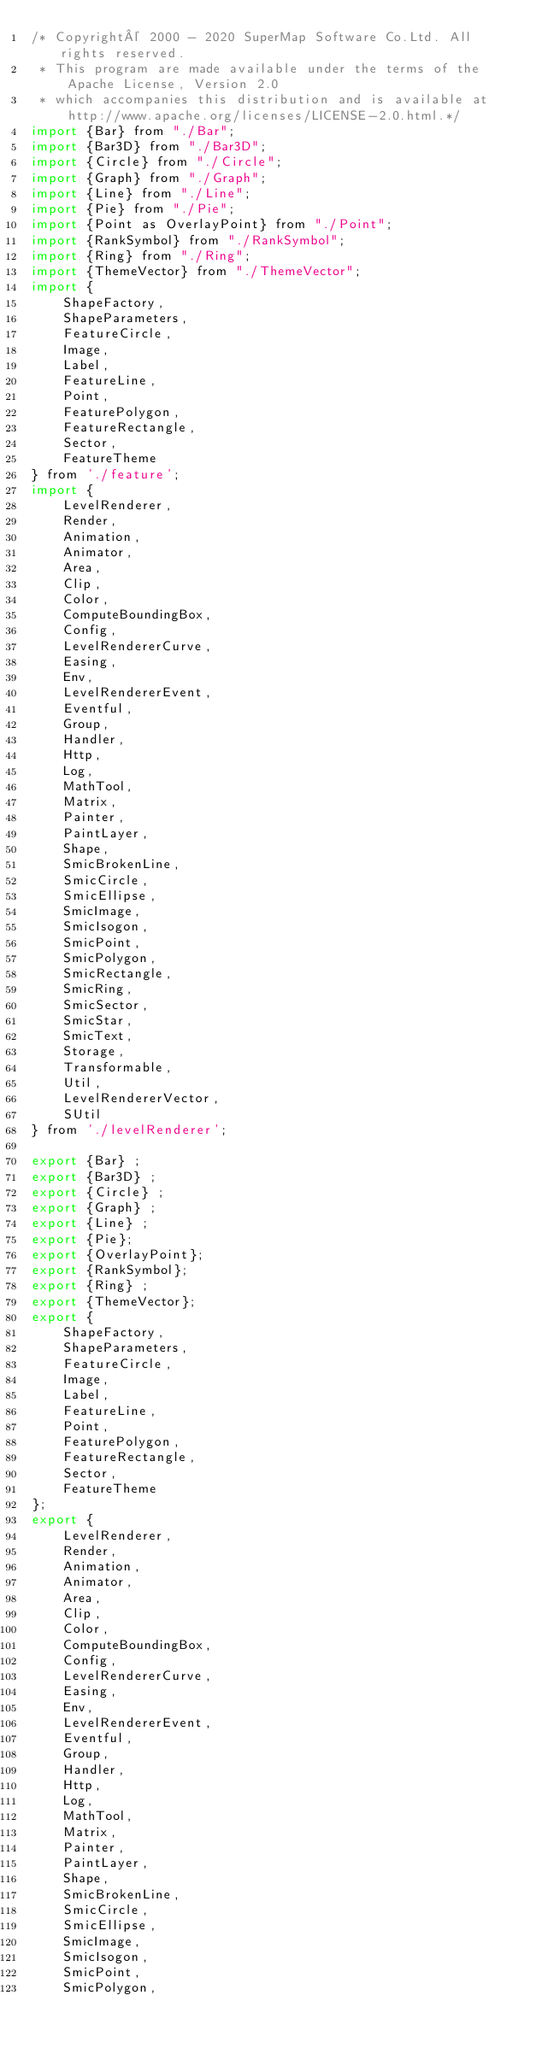Convert code to text. <code><loc_0><loc_0><loc_500><loc_500><_JavaScript_>/* Copyright© 2000 - 2020 SuperMap Software Co.Ltd. All rights reserved.
 * This program are made available under the terms of the Apache License, Version 2.0
 * which accompanies this distribution and is available at http://www.apache.org/licenses/LICENSE-2.0.html.*/
import {Bar} from "./Bar";
import {Bar3D} from "./Bar3D";
import {Circle} from "./Circle";
import {Graph} from "./Graph";
import {Line} from "./Line";
import {Pie} from "./Pie";
import {Point as OverlayPoint} from "./Point";
import {RankSymbol} from "./RankSymbol";
import {Ring} from "./Ring";
import {ThemeVector} from "./ThemeVector";
import {
    ShapeFactory,
    ShapeParameters,
    FeatureCircle,
    Image,
    Label,
    FeatureLine,
    Point,
    FeaturePolygon,
    FeatureRectangle,
    Sector,
    FeatureTheme
} from './feature';
import {
    LevelRenderer,
    Render,
    Animation,
    Animator,
    Area,
    Clip,
    Color,
    ComputeBoundingBox,
    Config,
    LevelRendererCurve,
    Easing,
    Env,
    LevelRendererEvent,
    Eventful,
    Group,
    Handler,
    Http,
    Log,
    MathTool,
    Matrix,
    Painter,
    PaintLayer,
    Shape,
    SmicBrokenLine,
    SmicCircle,
    SmicEllipse,
    SmicImage,
    SmicIsogon,
    SmicPoint,
    SmicPolygon,
    SmicRectangle,
    SmicRing,
    SmicSector,
    SmicStar,
    SmicText,
    Storage,
    Transformable,
    Util,
    LevelRendererVector,
    SUtil
} from './levelRenderer';

export {Bar} ;
export {Bar3D} ;
export {Circle} ;
export {Graph} ;
export {Line} ;
export {Pie};
export {OverlayPoint};
export {RankSymbol};
export {Ring} ;
export {ThemeVector};
export {
    ShapeFactory,
    ShapeParameters,
    FeatureCircle,
    Image,
    Label,
    FeatureLine,
    Point,
    FeaturePolygon,
    FeatureRectangle,
    Sector,
    FeatureTheme
};
export {
    LevelRenderer,
    Render,
    Animation,
    Animator,
    Area,
    Clip,
    Color,
    ComputeBoundingBox,
    Config,
    LevelRendererCurve,
    Easing,
    Env,
    LevelRendererEvent,
    Eventful,
    Group,
    Handler,
    Http,
    Log,
    MathTool,
    Matrix,
    Painter,
    PaintLayer,
    Shape,
    SmicBrokenLine,
    SmicCircle,
    SmicEllipse,
    SmicImage,
    SmicIsogon,
    SmicPoint,
    SmicPolygon,</code> 